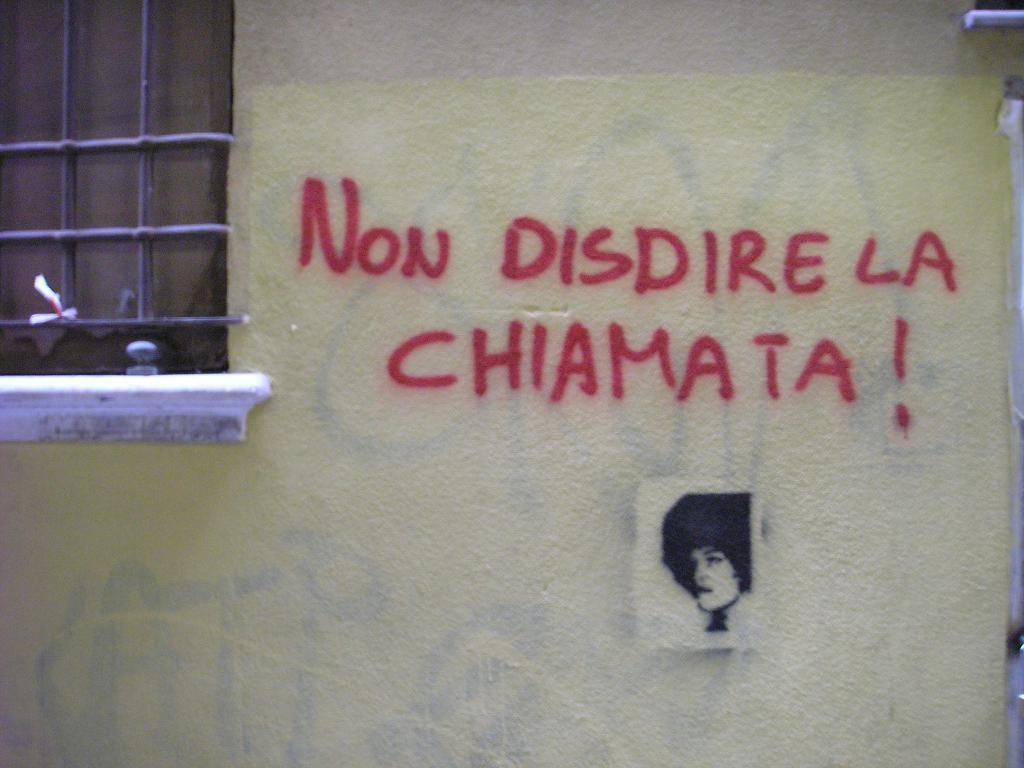What is present on the wall in the image? There is text on the wall in the image. Is there anything else on the wall besides the text? Yes, there is a picture of a person below the text on the wall. Can you describe the window on the wall? There is a window on the left side of the wall in the image. Where is the mailbox located in the image? There is no mailbox present in the image. What type of kite is being flown by the person in the image? There is no kite or person visible in the image; only the wall, text, and window are present. 